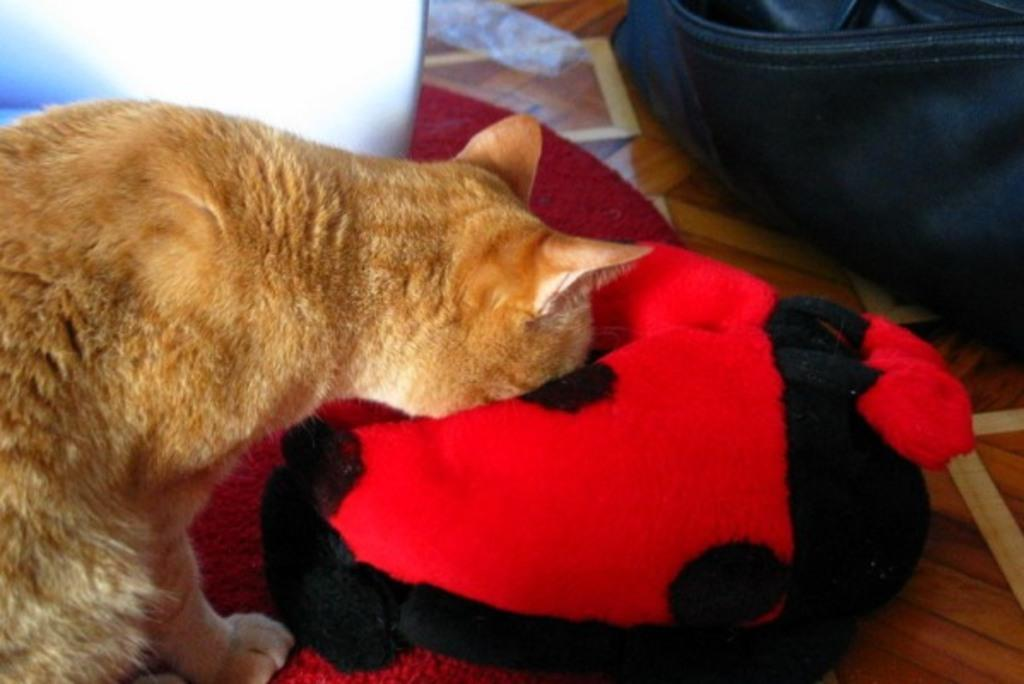What type of animal is in the image? There is a cat in the image. Can you describe the color pattern of the cat? The cat is brown and white in color. What is the color and pattern of the pillow in the image? The pillow in the image is red and black in color. What is the color and material of the mat in the image? The mat in the image is red in color and appears to be made of a soft material. What is the color and pattern of the object in the image? The object in the image is black and white in color. How many jellyfish can be seen swimming in the image? There are no jellyfish present in the image; it features a cat, a pillow, a mat, and an object. What time does the clock in the image show? There is no clock present in the image. 